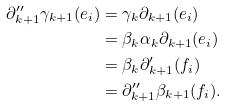Convert formula to latex. <formula><loc_0><loc_0><loc_500><loc_500>\partial ^ { \prime \prime } _ { k + 1 } \gamma _ { k + 1 } ( e _ { i } ) & = \gamma _ { k } \partial _ { k + 1 } ( e _ { i } ) \\ & = \beta _ { k } \alpha _ { k } \partial _ { k + 1 } ( e _ { i } ) \\ & = \beta _ { k } \partial ^ { \prime } _ { k + 1 } ( f _ { i } ) \\ & = \partial ^ { \prime \prime } _ { k + 1 } \beta _ { k + 1 } ( f _ { i } ) .</formula> 